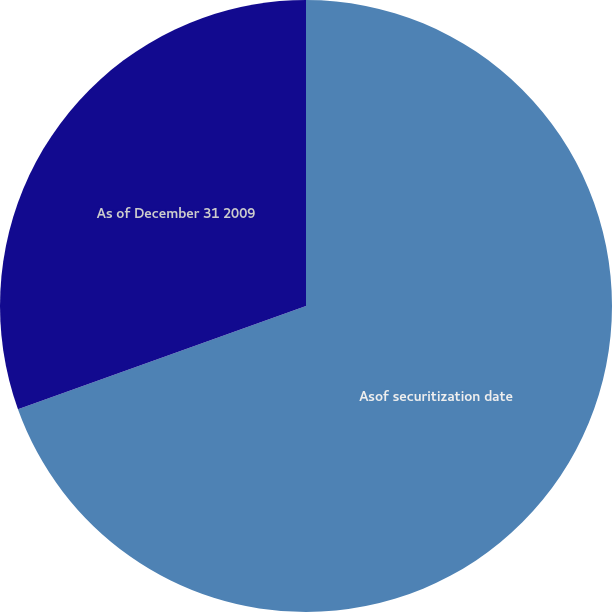Convert chart to OTSL. <chart><loc_0><loc_0><loc_500><loc_500><pie_chart><fcel>Asof securitization date<fcel>As of December 31 2009<nl><fcel>69.52%<fcel>30.48%<nl></chart> 